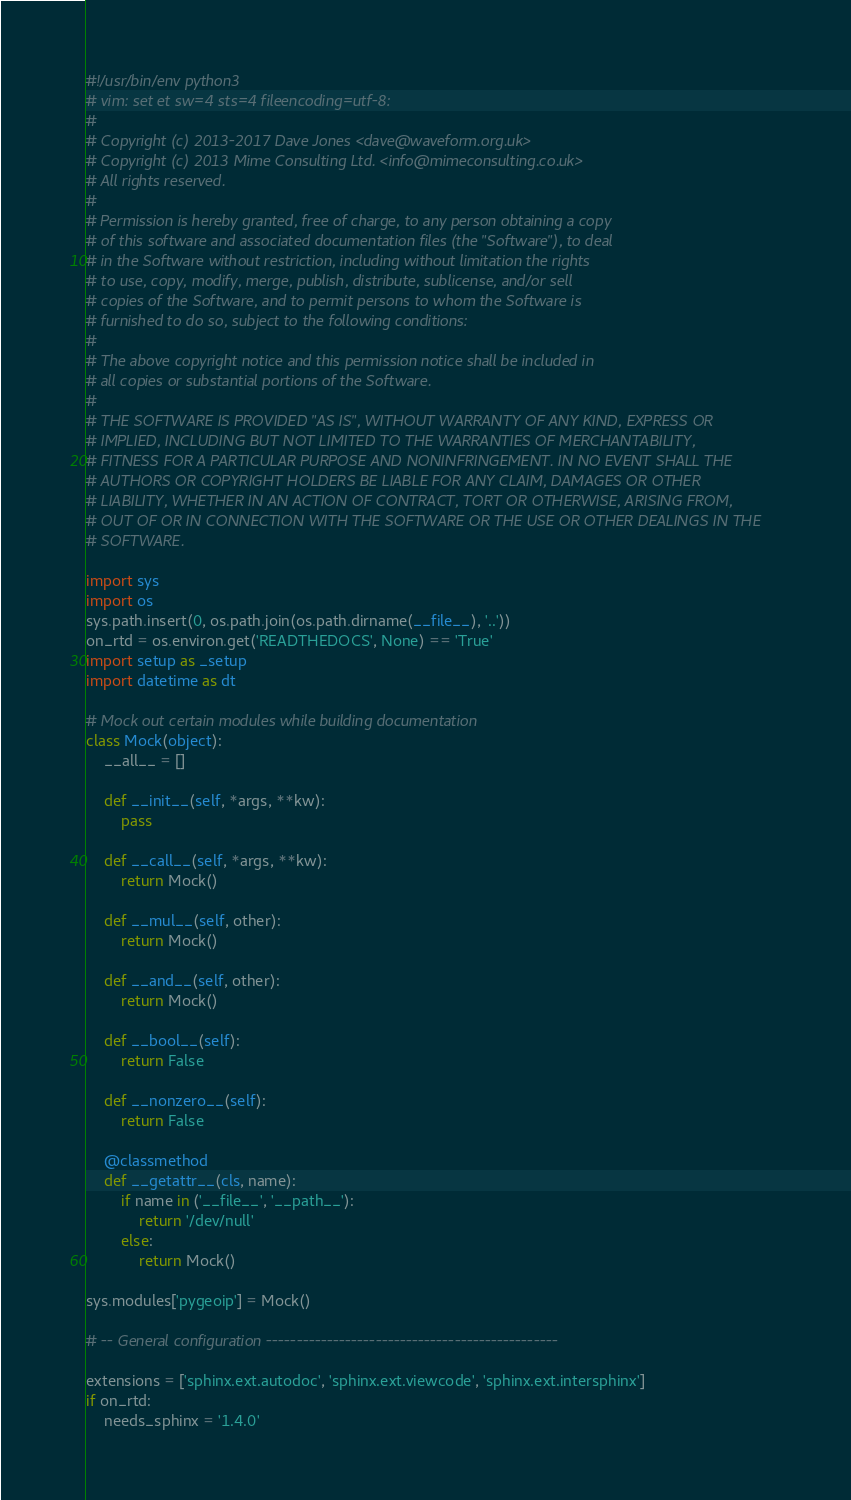Convert code to text. <code><loc_0><loc_0><loc_500><loc_500><_Python_>#!/usr/bin/env python3
# vim: set et sw=4 sts=4 fileencoding=utf-8:
#
# Copyright (c) 2013-2017 Dave Jones <dave@waveform.org.uk>
# Copyright (c) 2013 Mime Consulting Ltd. <info@mimeconsulting.co.uk>
# All rights reserved.
#
# Permission is hereby granted, free of charge, to any person obtaining a copy
# of this software and associated documentation files (the "Software"), to deal
# in the Software without restriction, including without limitation the rights
# to use, copy, modify, merge, publish, distribute, sublicense, and/or sell
# copies of the Software, and to permit persons to whom the Software is
# furnished to do so, subject to the following conditions:
#
# The above copyright notice and this permission notice shall be included in
# all copies or substantial portions of the Software.
#
# THE SOFTWARE IS PROVIDED "AS IS", WITHOUT WARRANTY OF ANY KIND, EXPRESS OR
# IMPLIED, INCLUDING BUT NOT LIMITED TO THE WARRANTIES OF MERCHANTABILITY,
# FITNESS FOR A PARTICULAR PURPOSE AND NONINFRINGEMENT. IN NO EVENT SHALL THE
# AUTHORS OR COPYRIGHT HOLDERS BE LIABLE FOR ANY CLAIM, DAMAGES OR OTHER
# LIABILITY, WHETHER IN AN ACTION OF CONTRACT, TORT OR OTHERWISE, ARISING FROM,
# OUT OF OR IN CONNECTION WITH THE SOFTWARE OR THE USE OR OTHER DEALINGS IN THE
# SOFTWARE.

import sys
import os
sys.path.insert(0, os.path.join(os.path.dirname(__file__), '..'))
on_rtd = os.environ.get('READTHEDOCS', None) == 'True'
import setup as _setup
import datetime as dt

# Mock out certain modules while building documentation
class Mock(object):
    __all__ = []

    def __init__(self, *args, **kw):
        pass

    def __call__(self, *args, **kw):
        return Mock()

    def __mul__(self, other):
        return Mock()

    def __and__(self, other):
        return Mock()

    def __bool__(self):
        return False

    def __nonzero__(self):
        return False

    @classmethod
    def __getattr__(cls, name):
        if name in ('__file__', '__path__'):
            return '/dev/null'
        else:
            return Mock()

sys.modules['pygeoip'] = Mock()

# -- General configuration ------------------------------------------------

extensions = ['sphinx.ext.autodoc', 'sphinx.ext.viewcode', 'sphinx.ext.intersphinx']
if on_rtd:
    needs_sphinx = '1.4.0'</code> 